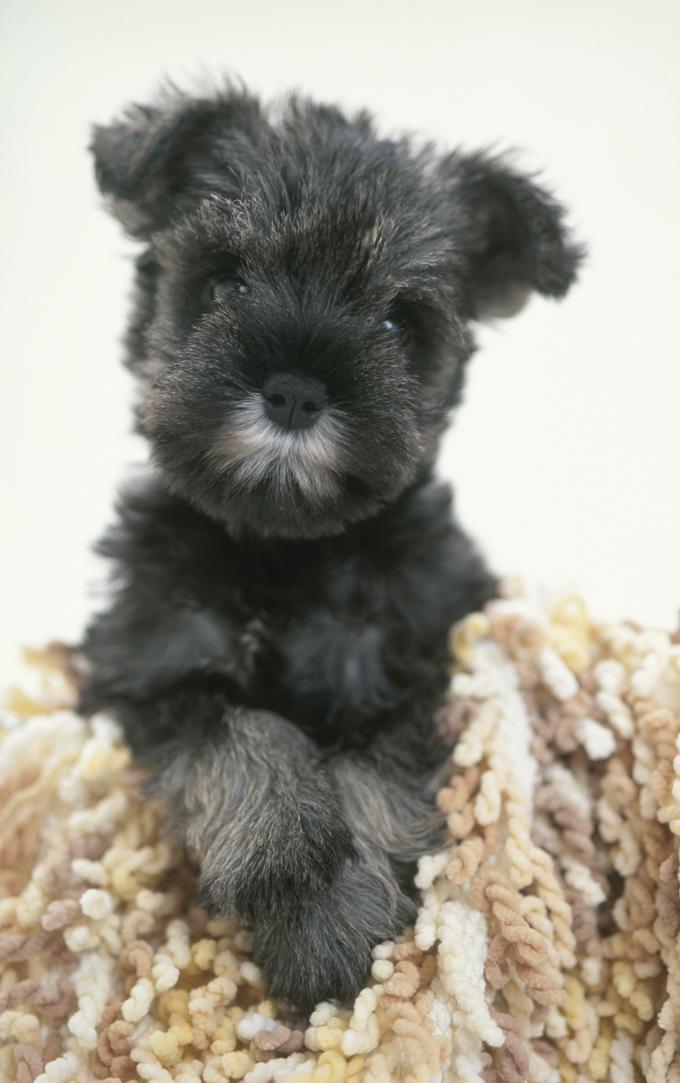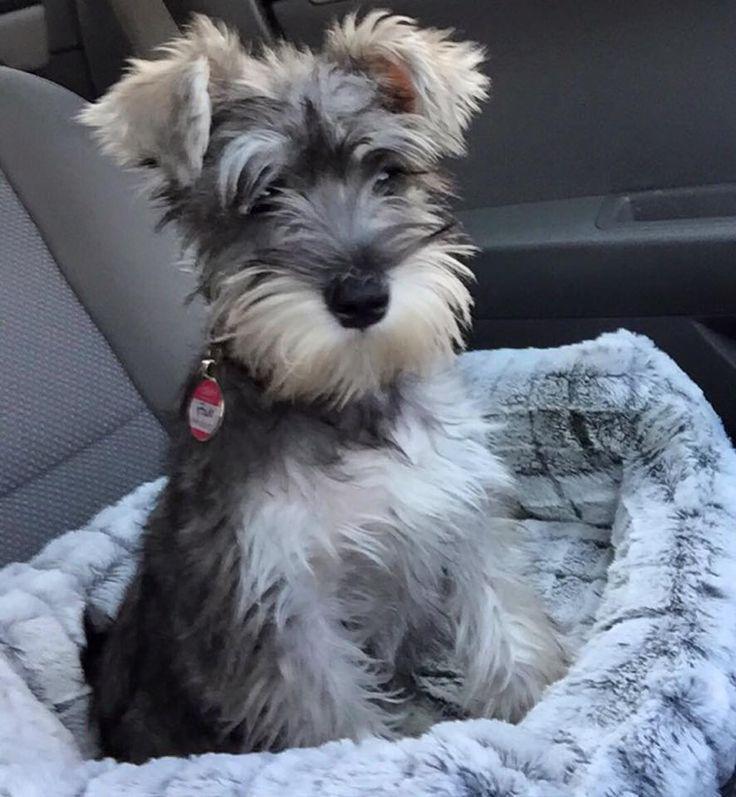The first image is the image on the left, the second image is the image on the right. Analyze the images presented: Is the assertion "AT least one dog is wearing a collar." valid? Answer yes or no. Yes. The first image is the image on the left, the second image is the image on the right. Examine the images to the left and right. Is the description "The dog in the left image is facing towards the right." accurate? Answer yes or no. No. The first image is the image on the left, the second image is the image on the right. Analyze the images presented: Is the assertion "The dog in the left photo is biting something." valid? Answer yes or no. No. The first image is the image on the left, the second image is the image on the right. For the images shown, is this caption "In one image, a little dog with ears flopping forward has a blue toy at its front feet." true? Answer yes or no. No. 